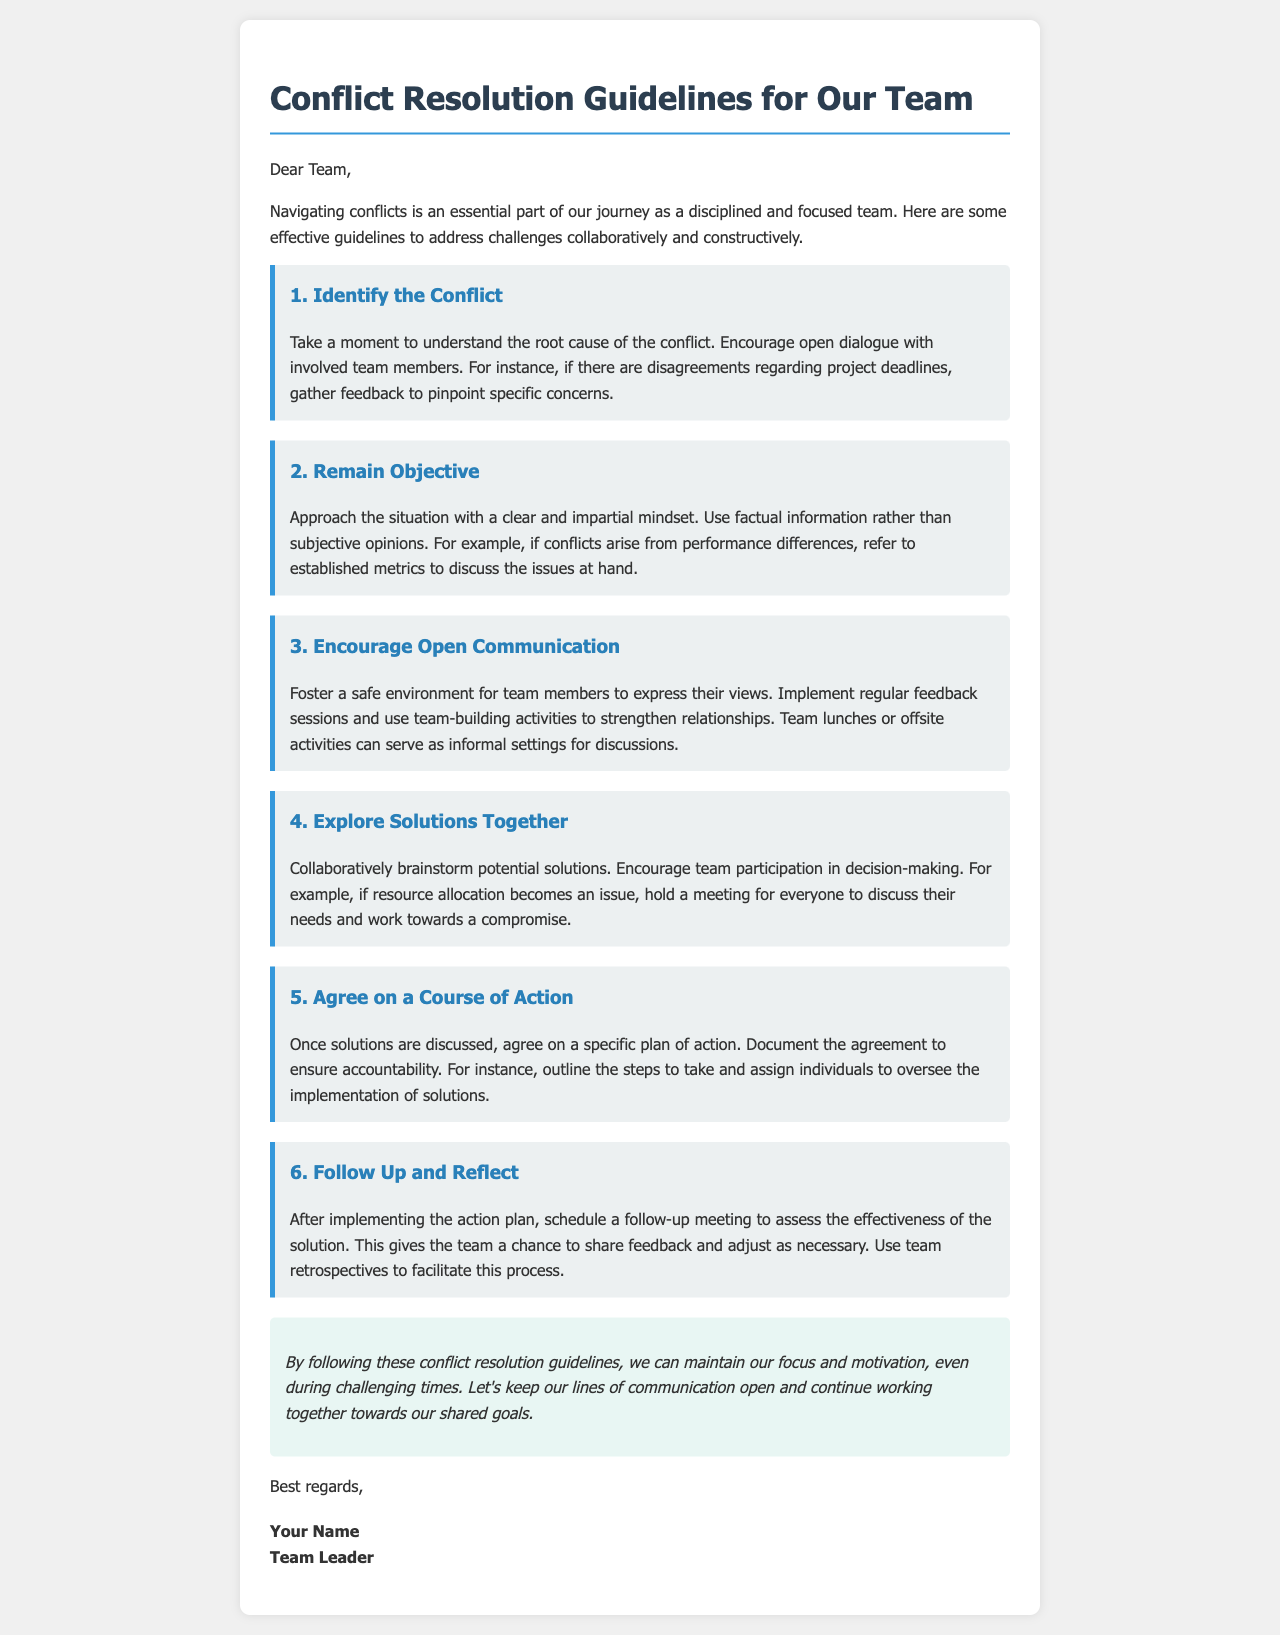What is the subject of the email? The subject of the email outlines the main focus and purpose, which is to provide guidelines for handling conflicts within the team.
Answer: Conflict Resolution Guidelines for Our Team How many guidelines are provided in the document? The document lists six specific guidelines for resolving conflicts effectively.
Answer: 6 What is the first step mentioned in the resolution process? The first step involves understanding the root cause of the conflict and encouraging open dialogue among team members.
Answer: Identify the Conflict Which guideline emphasizes the importance of communication? The guideline focusing on communication encourages fostering a safe environment for team members to express their views.
Answer: Encourage Open Communication What action is outlined in the fifth guideline? The fifth guideline instructs the team to agree on a specific plan of action after discussing potential solutions.
Answer: Agree on a Course of Action What is the conclusive message of the email? The conclusion emphasizes maintaining focus and motivation while keeping communication lines open.
Answer: Let's keep our lines of communication open and continue working together towards our shared goals 